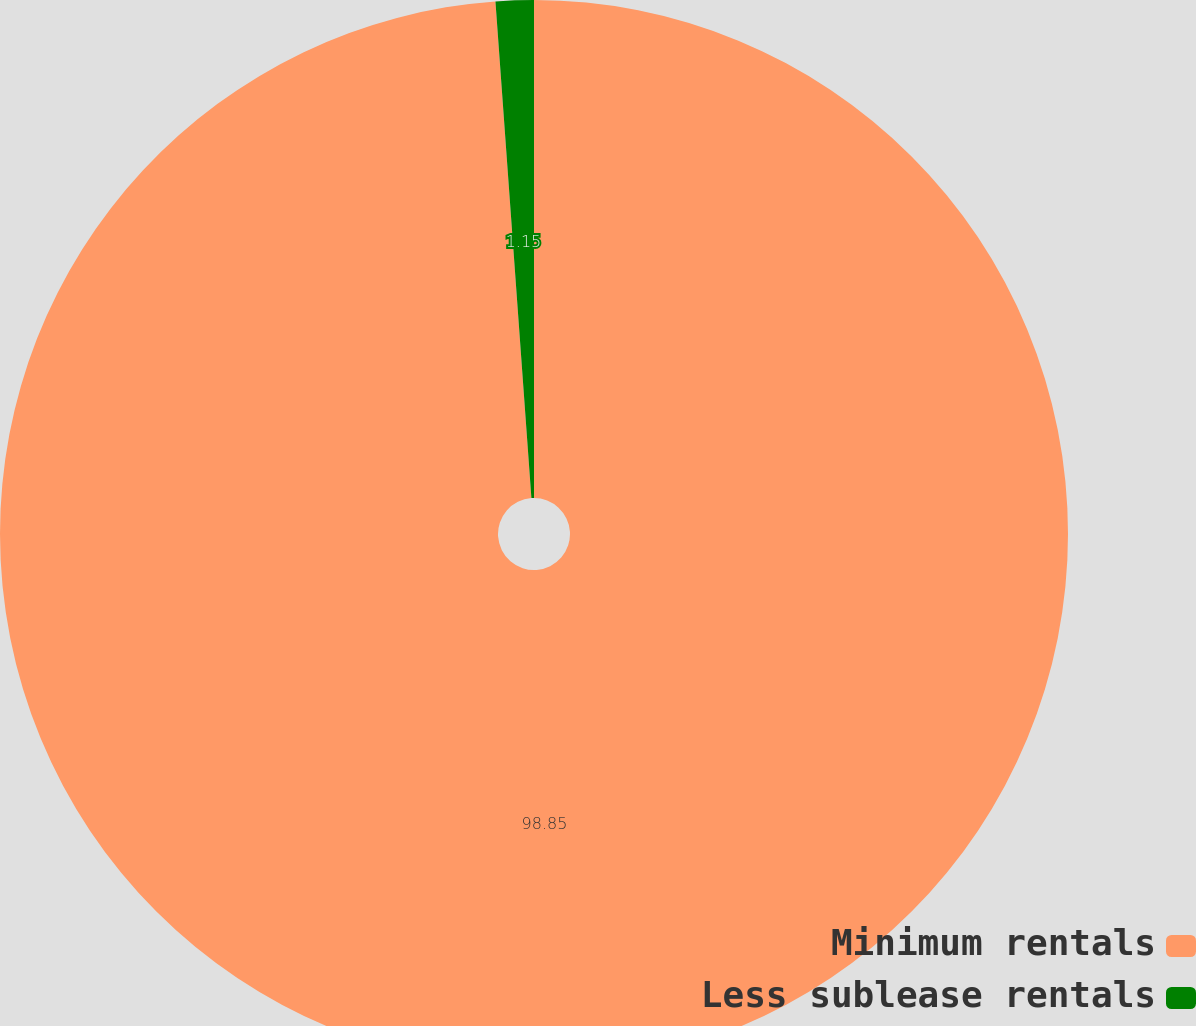Convert chart. <chart><loc_0><loc_0><loc_500><loc_500><pie_chart><fcel>Minimum rentals<fcel>Less sublease rentals<nl><fcel>98.85%<fcel>1.15%<nl></chart> 